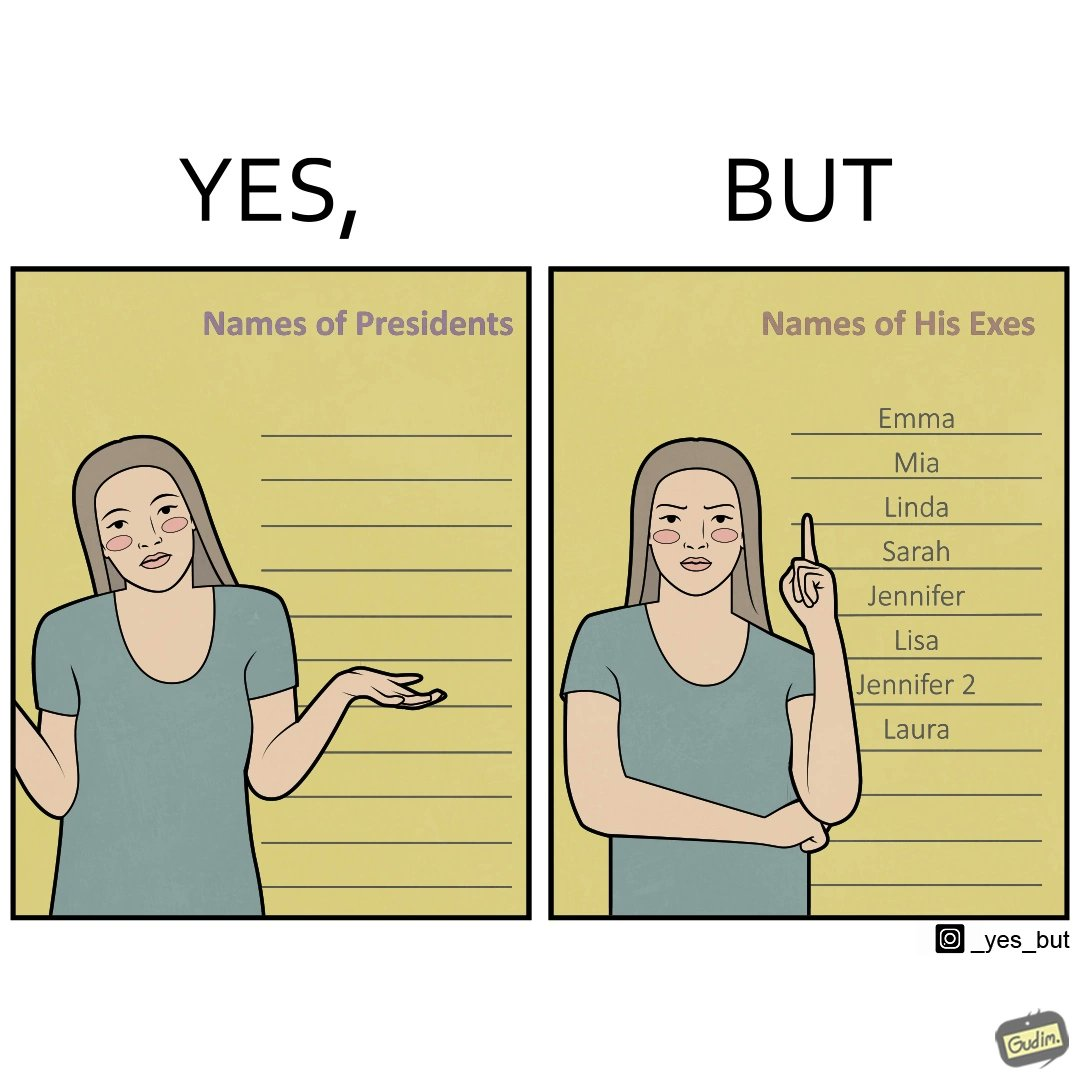Does this image contain satire or humor? Yes, this image is satirical. 